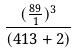Convert formula to latex. <formula><loc_0><loc_0><loc_500><loc_500>\frac { ( \frac { 8 9 } { 1 } ) ^ { 3 } } { ( 4 1 3 + 2 ) }</formula> 